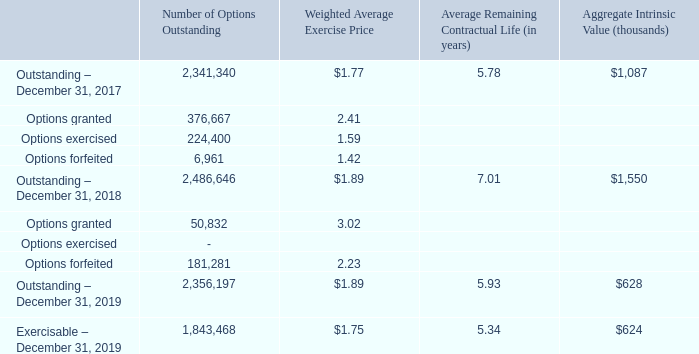STOCK OPTIONS
The following is a summary of stock option activity during the years ended December 31, 2019 and 2018:
What are the respective outstanding options as at December 31, 2017 and 2018? 2,341,340, 2,486,646. What are the respective outstanding options as at December 31, 2018 and 2019? 2,486,646, 2,356,197. What are the respective outstanding and exercisable options at December 31, 2019? 2,356,197, 1,843,468. What is the average number of outstanding options as at December 31, 2017 and 2018? (2,341,340 + 2,486,646)/2 
Answer: 2413993. What is the percentage change in outstanding options between 2017 and 2018?
Answer scale should be: percent. (2,486,646 - 2,341,340)/2,341,340 
Answer: 6.21. What is the percentage change in outstanding options between 2018 and 2019?
Answer scale should be: percent. (2,356,197 - 2,486,646)/2,486,646 
Answer: -5.25. 